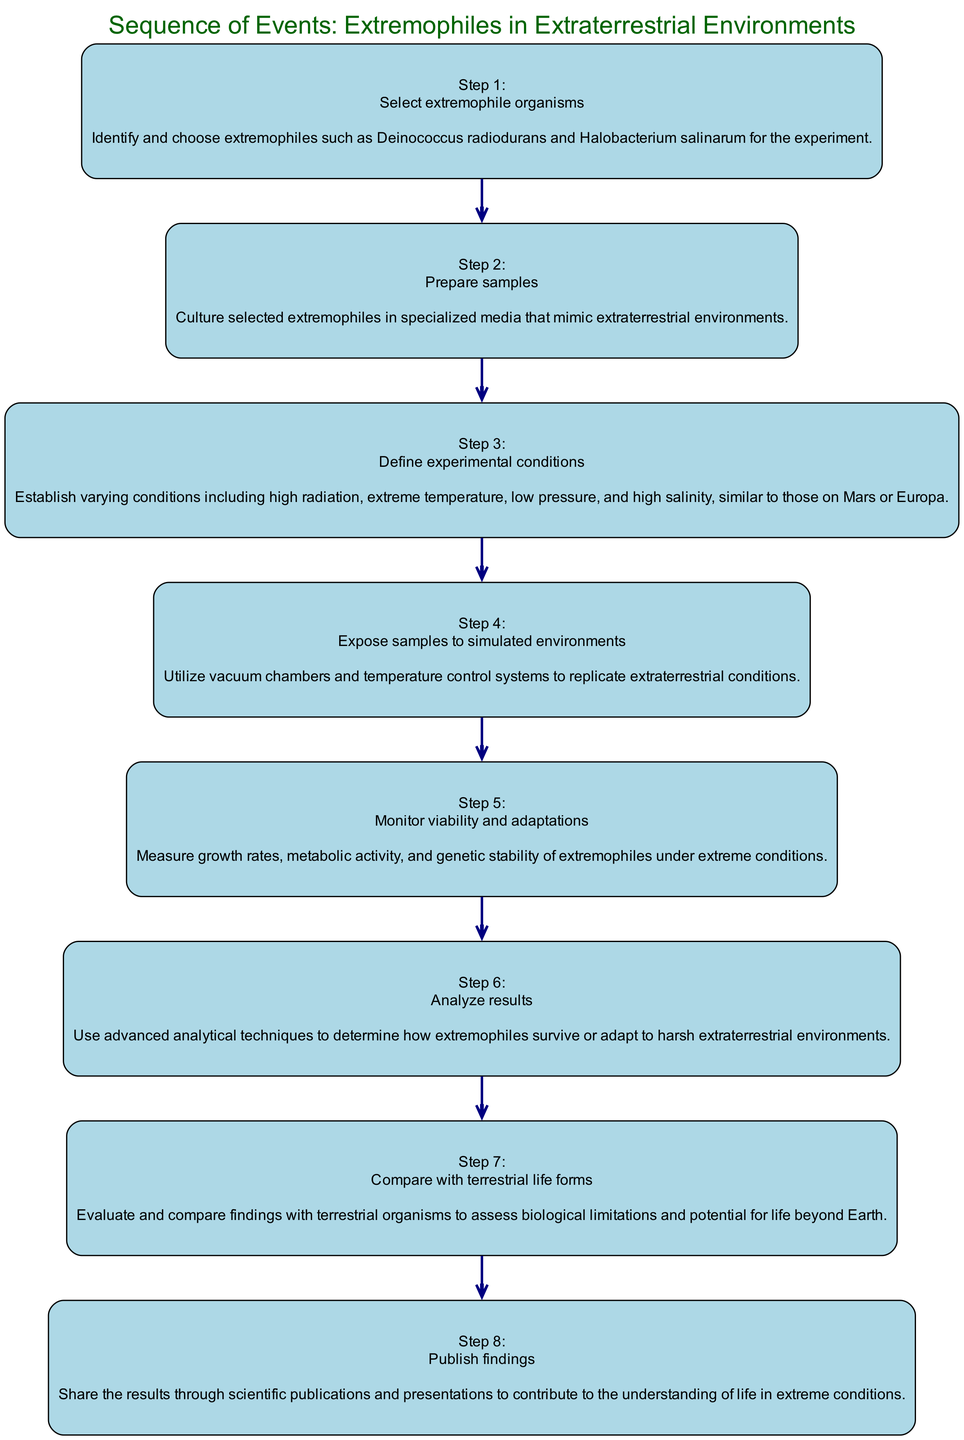What is the first action in the experiment? The diagram shows that the first action is to "Select extremophile organisms," which is indicated as step 1 in the sequence.
Answer: Select extremophile organisms How many steps are in the sequence? By counting each unique step listed in the diagram, there are a total of 8 steps in the sequence of events.
Answer: 8 What action follows "Analyze results"? Looking at the sequence, the action that follows "Analyze results" (step 6) is "Compare with terrestrial life forms," which is step 7 in the sequence.
Answer: Compare with terrestrial life forms What is the last action in the experiment? The diagram shows that the last action is "Publish findings," which is labeled as step 8, indicating that the experiment culminates in sharing the results.
Answer: Publish findings What is one experimental condition defined in step 3? Step 3 indicates that experimental conditions include elements such as "high radiation," which is specifically mentioned as part of the definition of those conditions.
Answer: high radiation How does the action of “Expose samples to simulated environments” relate to preparing samples? The action of exposing samples (step 4) comes after the preparation of samples (step 2), indicating a sequential process where samples must first be prepared before they can be exposed to environments.
Answer: Expose samples to simulated environments follows preparing samples What is the main purpose of comparing findings with terrestrial life forms? This step is aimed at assessing the biological limitations and potential for life beyond Earth, as described in the corresponding action in the diagram.
Answer: Assess biological limitations Which action precedes the monitoring of viability and adaptations? By examining the steps, it becomes clear that the action that precedes monitoring viability and adaptations is "Expose samples to simulated environments," which is step 4.
Answer: Expose samples to simulated environments 